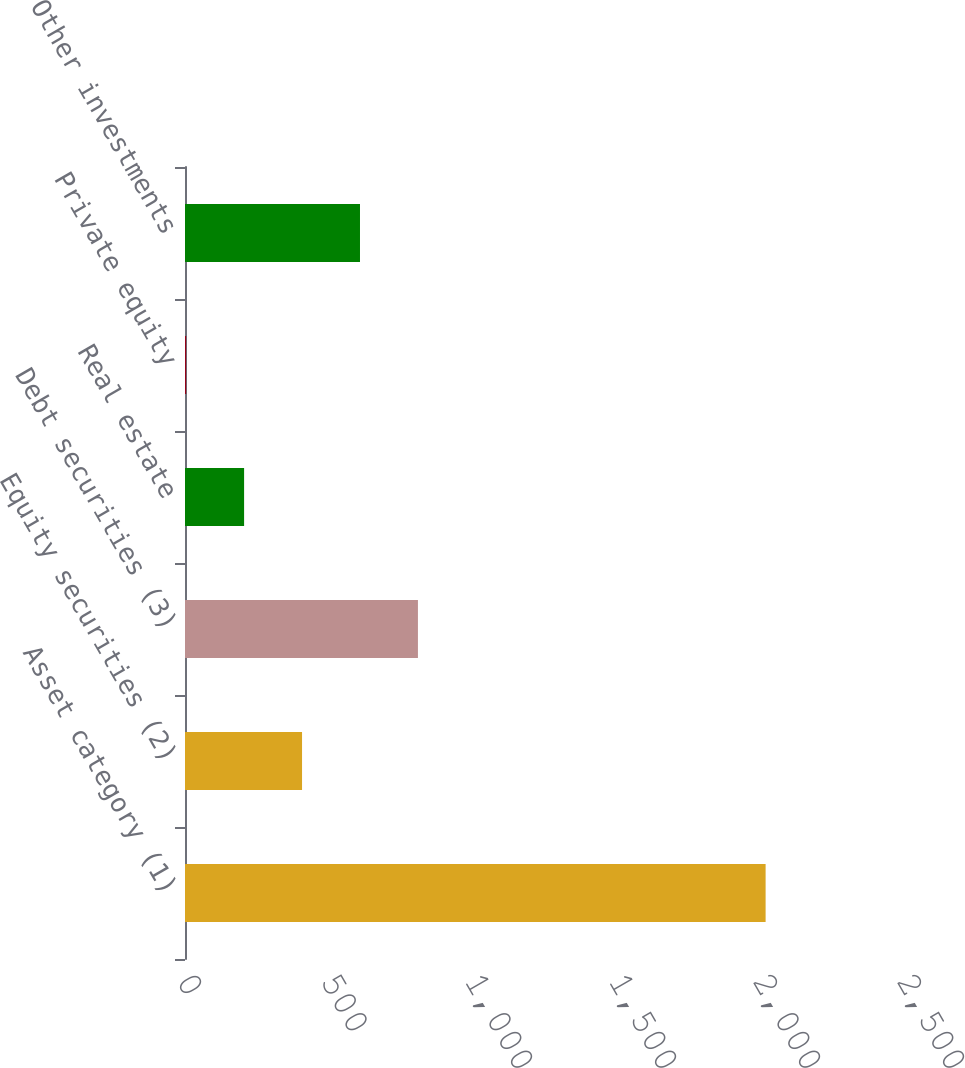<chart> <loc_0><loc_0><loc_500><loc_500><bar_chart><fcel>Asset category (1)<fcel>Equity securities (2)<fcel>Debt securities (3)<fcel>Real estate<fcel>Private equity<fcel>Other investments<nl><fcel>2016<fcel>406.4<fcel>808.8<fcel>205.2<fcel>4<fcel>607.6<nl></chart> 